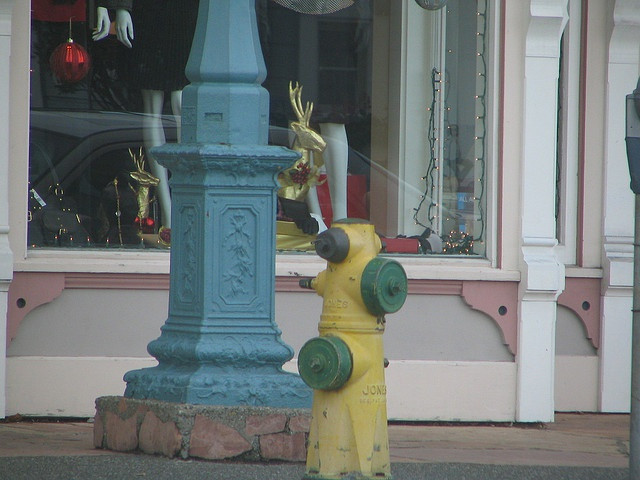Describe the objects in this image and their specific colors. I can see a fire hydrant in gray, tan, teal, and olive tones in this image. 